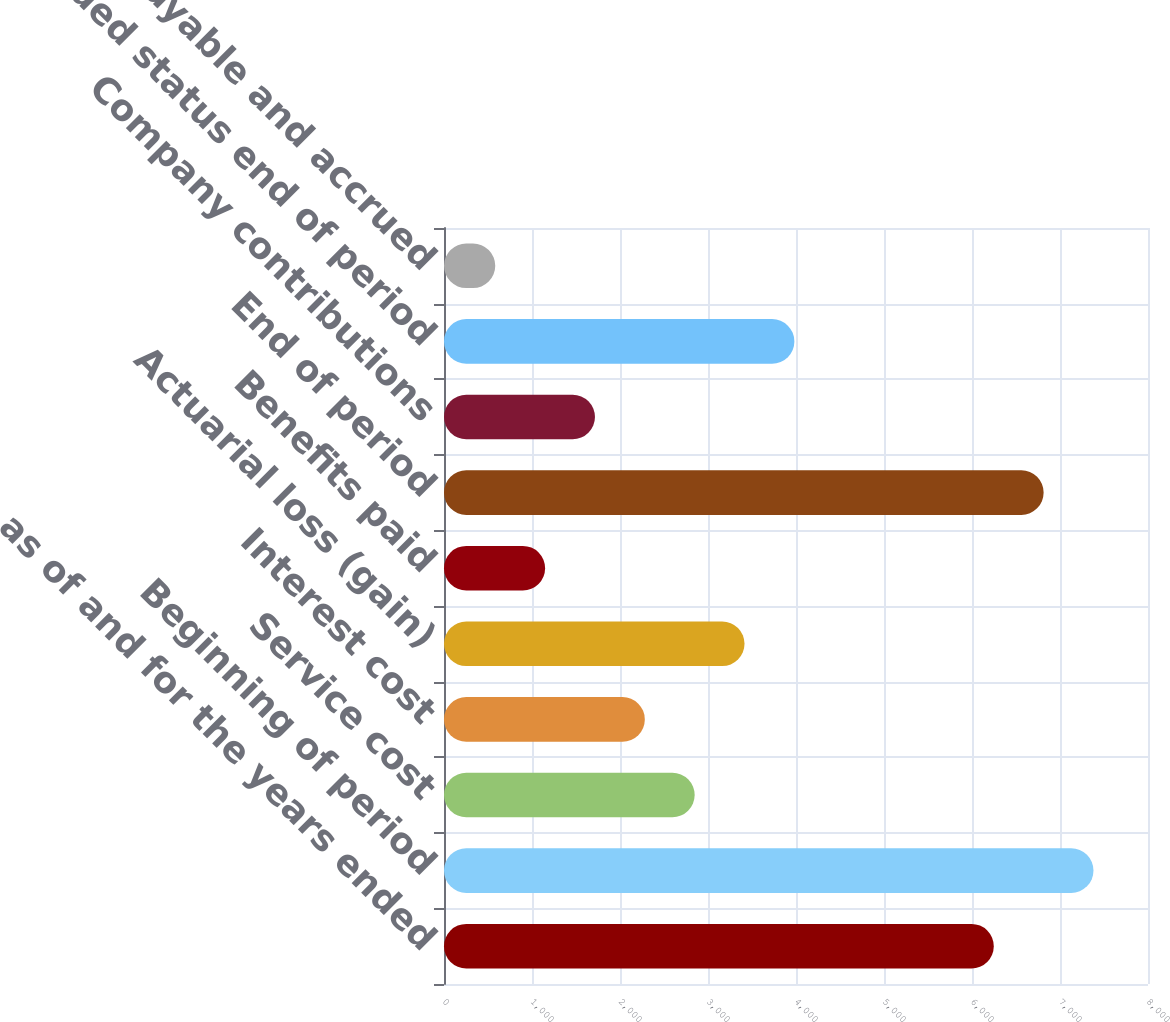<chart> <loc_0><loc_0><loc_500><loc_500><bar_chart><fcel>as of and for the years ended<fcel>Beginning of period<fcel>Service cost<fcel>Interest cost<fcel>Actuarial loss (gain)<fcel>Benefits paid<fcel>End of period<fcel>Company contributions<fcel>Funded status end of period<fcel>Accounts payable and accrued<nl><fcel>6247.5<fcel>7380.5<fcel>2848.5<fcel>2282<fcel>3415<fcel>1149<fcel>6814<fcel>1715.5<fcel>3981.5<fcel>582.5<nl></chart> 